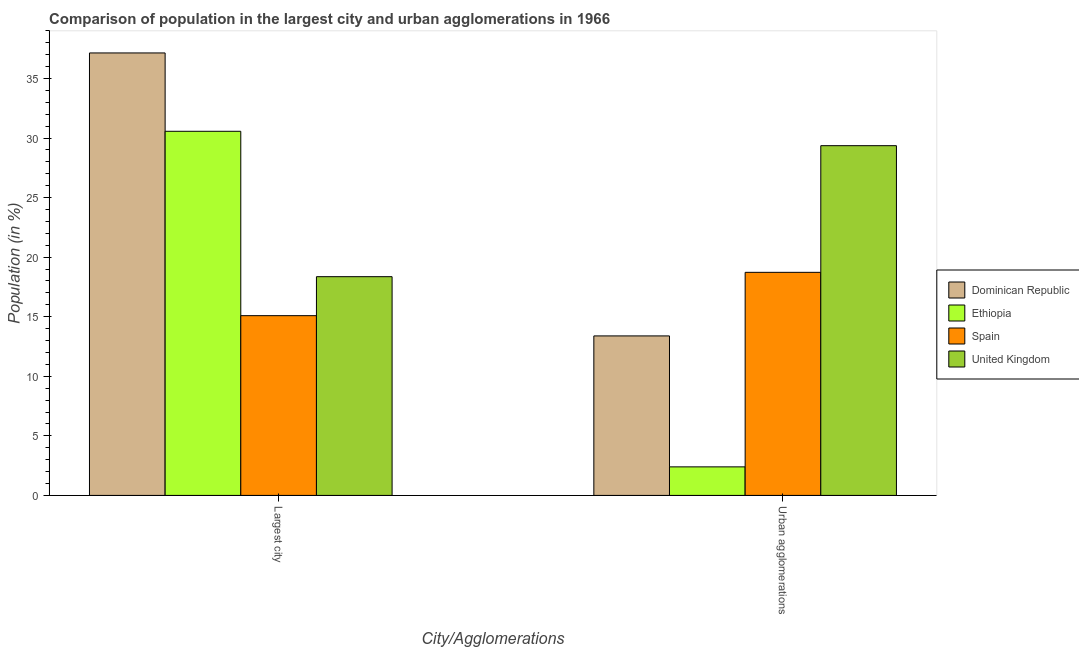How many different coloured bars are there?
Offer a terse response. 4. How many groups of bars are there?
Make the answer very short. 2. What is the label of the 1st group of bars from the left?
Your answer should be compact. Largest city. What is the population in the largest city in Ethiopia?
Offer a terse response. 30.57. Across all countries, what is the maximum population in the largest city?
Give a very brief answer. 37.14. Across all countries, what is the minimum population in the largest city?
Ensure brevity in your answer.  15.09. In which country was the population in urban agglomerations maximum?
Your answer should be compact. United Kingdom. In which country was the population in urban agglomerations minimum?
Ensure brevity in your answer.  Ethiopia. What is the total population in urban agglomerations in the graph?
Offer a very short reply. 63.87. What is the difference between the population in urban agglomerations in Ethiopia and that in Spain?
Offer a terse response. -16.33. What is the difference between the population in the largest city in Spain and the population in urban agglomerations in Ethiopia?
Offer a terse response. 12.69. What is the average population in urban agglomerations per country?
Keep it short and to the point. 15.97. What is the difference between the population in urban agglomerations and population in the largest city in Ethiopia?
Offer a very short reply. -28.17. In how many countries, is the population in the largest city greater than 32 %?
Offer a very short reply. 1. What is the ratio of the population in the largest city in Spain to that in Ethiopia?
Offer a very short reply. 0.49. Is the population in urban agglomerations in Ethiopia less than that in Dominican Republic?
Keep it short and to the point. Yes. What does the 1st bar from the left in Largest city represents?
Make the answer very short. Dominican Republic. What does the 3rd bar from the right in Largest city represents?
Your response must be concise. Ethiopia. How many bars are there?
Ensure brevity in your answer.  8. Are all the bars in the graph horizontal?
Give a very brief answer. No. What is the difference between two consecutive major ticks on the Y-axis?
Your answer should be compact. 5. Does the graph contain grids?
Make the answer very short. No. Where does the legend appear in the graph?
Provide a succinct answer. Center right. How many legend labels are there?
Ensure brevity in your answer.  4. What is the title of the graph?
Ensure brevity in your answer.  Comparison of population in the largest city and urban agglomerations in 1966. What is the label or title of the X-axis?
Offer a terse response. City/Agglomerations. What is the Population (in %) in Dominican Republic in Largest city?
Offer a terse response. 37.14. What is the Population (in %) in Ethiopia in Largest city?
Your answer should be very brief. 30.57. What is the Population (in %) in Spain in Largest city?
Make the answer very short. 15.09. What is the Population (in %) in United Kingdom in Largest city?
Keep it short and to the point. 18.36. What is the Population (in %) in Dominican Republic in Urban agglomerations?
Offer a very short reply. 13.39. What is the Population (in %) in Ethiopia in Urban agglomerations?
Keep it short and to the point. 2.4. What is the Population (in %) in Spain in Urban agglomerations?
Your response must be concise. 18.73. What is the Population (in %) of United Kingdom in Urban agglomerations?
Ensure brevity in your answer.  29.36. Across all City/Agglomerations, what is the maximum Population (in %) of Dominican Republic?
Ensure brevity in your answer.  37.14. Across all City/Agglomerations, what is the maximum Population (in %) in Ethiopia?
Offer a terse response. 30.57. Across all City/Agglomerations, what is the maximum Population (in %) of Spain?
Ensure brevity in your answer.  18.73. Across all City/Agglomerations, what is the maximum Population (in %) of United Kingdom?
Offer a terse response. 29.36. Across all City/Agglomerations, what is the minimum Population (in %) in Dominican Republic?
Provide a short and direct response. 13.39. Across all City/Agglomerations, what is the minimum Population (in %) in Ethiopia?
Offer a very short reply. 2.4. Across all City/Agglomerations, what is the minimum Population (in %) in Spain?
Offer a terse response. 15.09. Across all City/Agglomerations, what is the minimum Population (in %) in United Kingdom?
Provide a short and direct response. 18.36. What is the total Population (in %) in Dominican Republic in the graph?
Offer a very short reply. 50.53. What is the total Population (in %) in Ethiopia in the graph?
Your answer should be very brief. 32.96. What is the total Population (in %) in Spain in the graph?
Offer a very short reply. 33.82. What is the total Population (in %) in United Kingdom in the graph?
Your answer should be very brief. 47.72. What is the difference between the Population (in %) in Dominican Republic in Largest city and that in Urban agglomerations?
Keep it short and to the point. 23.75. What is the difference between the Population (in %) in Ethiopia in Largest city and that in Urban agglomerations?
Offer a very short reply. 28.17. What is the difference between the Population (in %) of Spain in Largest city and that in Urban agglomerations?
Ensure brevity in your answer.  -3.64. What is the difference between the Population (in %) in United Kingdom in Largest city and that in Urban agglomerations?
Your answer should be very brief. -11. What is the difference between the Population (in %) in Dominican Republic in Largest city and the Population (in %) in Ethiopia in Urban agglomerations?
Provide a short and direct response. 34.75. What is the difference between the Population (in %) in Dominican Republic in Largest city and the Population (in %) in Spain in Urban agglomerations?
Provide a short and direct response. 18.42. What is the difference between the Population (in %) in Dominican Republic in Largest city and the Population (in %) in United Kingdom in Urban agglomerations?
Your answer should be very brief. 7.78. What is the difference between the Population (in %) of Ethiopia in Largest city and the Population (in %) of Spain in Urban agglomerations?
Provide a succinct answer. 11.84. What is the difference between the Population (in %) in Ethiopia in Largest city and the Population (in %) in United Kingdom in Urban agglomerations?
Your response must be concise. 1.21. What is the difference between the Population (in %) in Spain in Largest city and the Population (in %) in United Kingdom in Urban agglomerations?
Your answer should be compact. -14.27. What is the average Population (in %) in Dominican Republic per City/Agglomerations?
Your response must be concise. 25.27. What is the average Population (in %) of Ethiopia per City/Agglomerations?
Provide a succinct answer. 16.48. What is the average Population (in %) of Spain per City/Agglomerations?
Offer a terse response. 16.91. What is the average Population (in %) of United Kingdom per City/Agglomerations?
Your answer should be very brief. 23.86. What is the difference between the Population (in %) of Dominican Republic and Population (in %) of Ethiopia in Largest city?
Offer a terse response. 6.58. What is the difference between the Population (in %) in Dominican Republic and Population (in %) in Spain in Largest city?
Give a very brief answer. 22.05. What is the difference between the Population (in %) in Dominican Republic and Population (in %) in United Kingdom in Largest city?
Provide a succinct answer. 18.78. What is the difference between the Population (in %) in Ethiopia and Population (in %) in Spain in Largest city?
Your answer should be compact. 15.48. What is the difference between the Population (in %) of Ethiopia and Population (in %) of United Kingdom in Largest city?
Offer a terse response. 12.2. What is the difference between the Population (in %) of Spain and Population (in %) of United Kingdom in Largest city?
Provide a succinct answer. -3.27. What is the difference between the Population (in %) of Dominican Republic and Population (in %) of Ethiopia in Urban agglomerations?
Make the answer very short. 10.99. What is the difference between the Population (in %) in Dominican Republic and Population (in %) in Spain in Urban agglomerations?
Make the answer very short. -5.34. What is the difference between the Population (in %) in Dominican Republic and Population (in %) in United Kingdom in Urban agglomerations?
Give a very brief answer. -15.97. What is the difference between the Population (in %) in Ethiopia and Population (in %) in Spain in Urban agglomerations?
Offer a terse response. -16.33. What is the difference between the Population (in %) of Ethiopia and Population (in %) of United Kingdom in Urban agglomerations?
Ensure brevity in your answer.  -26.96. What is the difference between the Population (in %) of Spain and Population (in %) of United Kingdom in Urban agglomerations?
Your answer should be very brief. -10.63. What is the ratio of the Population (in %) of Dominican Republic in Largest city to that in Urban agglomerations?
Provide a short and direct response. 2.77. What is the ratio of the Population (in %) in Ethiopia in Largest city to that in Urban agglomerations?
Keep it short and to the point. 12.76. What is the ratio of the Population (in %) in Spain in Largest city to that in Urban agglomerations?
Your answer should be very brief. 0.81. What is the ratio of the Population (in %) of United Kingdom in Largest city to that in Urban agglomerations?
Provide a succinct answer. 0.63. What is the difference between the highest and the second highest Population (in %) of Dominican Republic?
Your response must be concise. 23.75. What is the difference between the highest and the second highest Population (in %) in Ethiopia?
Your answer should be very brief. 28.17. What is the difference between the highest and the second highest Population (in %) in Spain?
Keep it short and to the point. 3.64. What is the difference between the highest and the second highest Population (in %) of United Kingdom?
Offer a very short reply. 11. What is the difference between the highest and the lowest Population (in %) in Dominican Republic?
Your answer should be very brief. 23.75. What is the difference between the highest and the lowest Population (in %) in Ethiopia?
Provide a short and direct response. 28.17. What is the difference between the highest and the lowest Population (in %) in Spain?
Give a very brief answer. 3.64. What is the difference between the highest and the lowest Population (in %) in United Kingdom?
Your answer should be very brief. 11. 